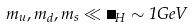<formula> <loc_0><loc_0><loc_500><loc_500>m _ { u } , m _ { d } , m _ { s } \ll \Lambda _ { H } \sim 1 G e V</formula> 